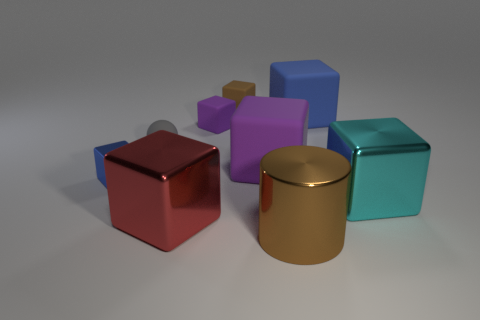Is the number of small green matte cubes less than the number of tiny rubber balls?
Make the answer very short. Yes. The other tiny metallic thing that is the same shape as the cyan object is what color?
Your response must be concise. Blue. Is there anything else that is the same shape as the tiny brown rubber object?
Your response must be concise. Yes. Is the number of blue cylinders greater than the number of brown matte blocks?
Make the answer very short. No. How many other things are the same material as the big cyan thing?
Give a very brief answer. 3. The brown thing right of the brown thing behind the blue object right of the tiny blue cube is what shape?
Your answer should be compact. Cylinder. Is the number of blue blocks on the right side of the small gray object less than the number of big metal cubes behind the tiny brown cube?
Provide a short and direct response. No. Is there a object that has the same color as the cylinder?
Make the answer very short. Yes. Are the big blue block and the brown object that is behind the large cyan metal thing made of the same material?
Ensure brevity in your answer.  Yes. Are there any spheres in front of the cyan thing right of the small blue metallic object?
Make the answer very short. No. 